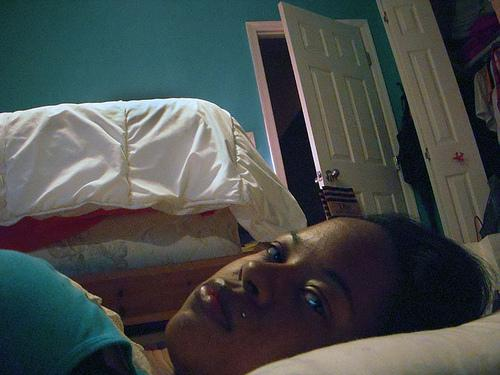Question: what type of room is this?
Choices:
A. Bedroom.
B. Bathroom.
C. Living room.
D. Dining room.
Answer with the letter. Answer: A Question: where is the closet?
Choices:
A. By the door.
B. In the bedroom.
C. In the hall.
D. In the laundry room.
Answer with the letter. Answer: A Question: who is in the photo?
Choices:
A. A man.
B. A child.
C. A woman.
D. A teenager.
Answer with the letter. Answer: C 